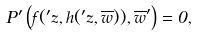<formula> <loc_0><loc_0><loc_500><loc_500>P ^ { \prime } \left ( f ( { ^ { \prime } z } , h ( { ^ { \prime } z } , \overline { w } ) ) , \overline { w } ^ { \prime } \right ) = 0 ,</formula> 